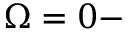Convert formula to latex. <formula><loc_0><loc_0><loc_500><loc_500>\Omega = 0 -</formula> 